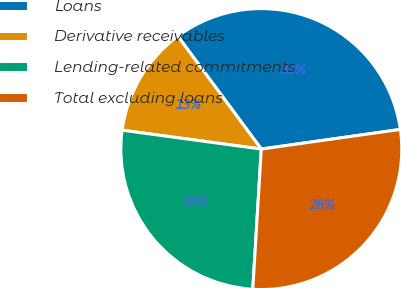Convert chart. <chart><loc_0><loc_0><loc_500><loc_500><pie_chart><fcel>Loans<fcel>Derivative receivables<fcel>Lending-related commitments<fcel>Total excluding loans<nl><fcel>32.91%<fcel>12.72%<fcel>26.18%<fcel>28.2%<nl></chart> 